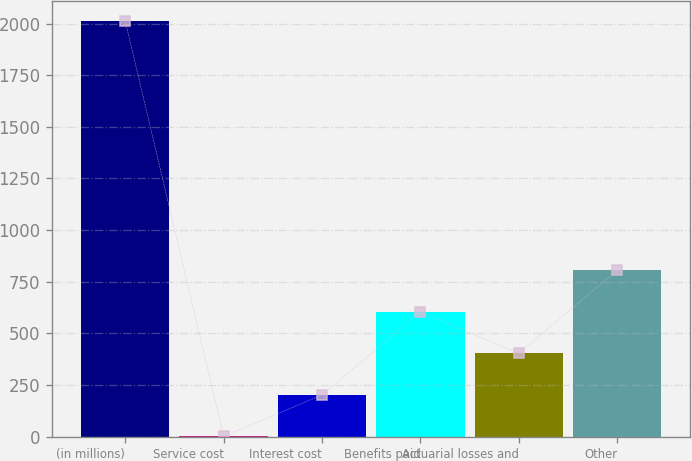Convert chart. <chart><loc_0><loc_0><loc_500><loc_500><bar_chart><fcel>(in millions)<fcel>Service cost<fcel>Interest cost<fcel>Benefits paid<fcel>Actuarial losses and<fcel>Other<nl><fcel>2011<fcel>1<fcel>202<fcel>604<fcel>403<fcel>805<nl></chart> 